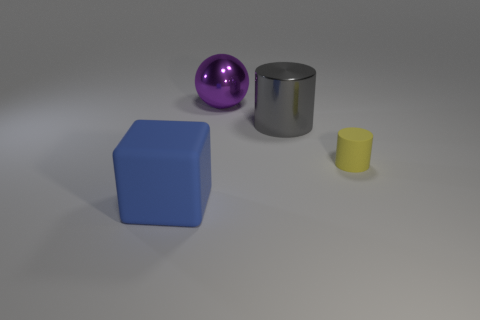Add 4 balls. How many objects exist? 8 Subtract all spheres. How many objects are left? 3 Subtract 0 green blocks. How many objects are left? 4 Subtract all small purple things. Subtract all big objects. How many objects are left? 1 Add 2 yellow matte things. How many yellow matte things are left? 3 Add 2 purple metal objects. How many purple metal objects exist? 3 